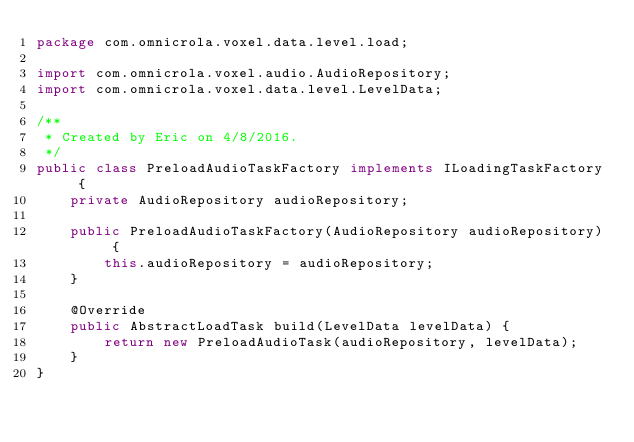<code> <loc_0><loc_0><loc_500><loc_500><_Java_>package com.omnicrola.voxel.data.level.load;

import com.omnicrola.voxel.audio.AudioRepository;
import com.omnicrola.voxel.data.level.LevelData;

/**
 * Created by Eric on 4/8/2016.
 */
public class PreloadAudioTaskFactory implements ILoadingTaskFactory {
    private AudioRepository audioRepository;

    public PreloadAudioTaskFactory(AudioRepository audioRepository) {
        this.audioRepository = audioRepository;
    }

    @Override
    public AbstractLoadTask build(LevelData levelData) {
        return new PreloadAudioTask(audioRepository, levelData);
    }
}
</code> 